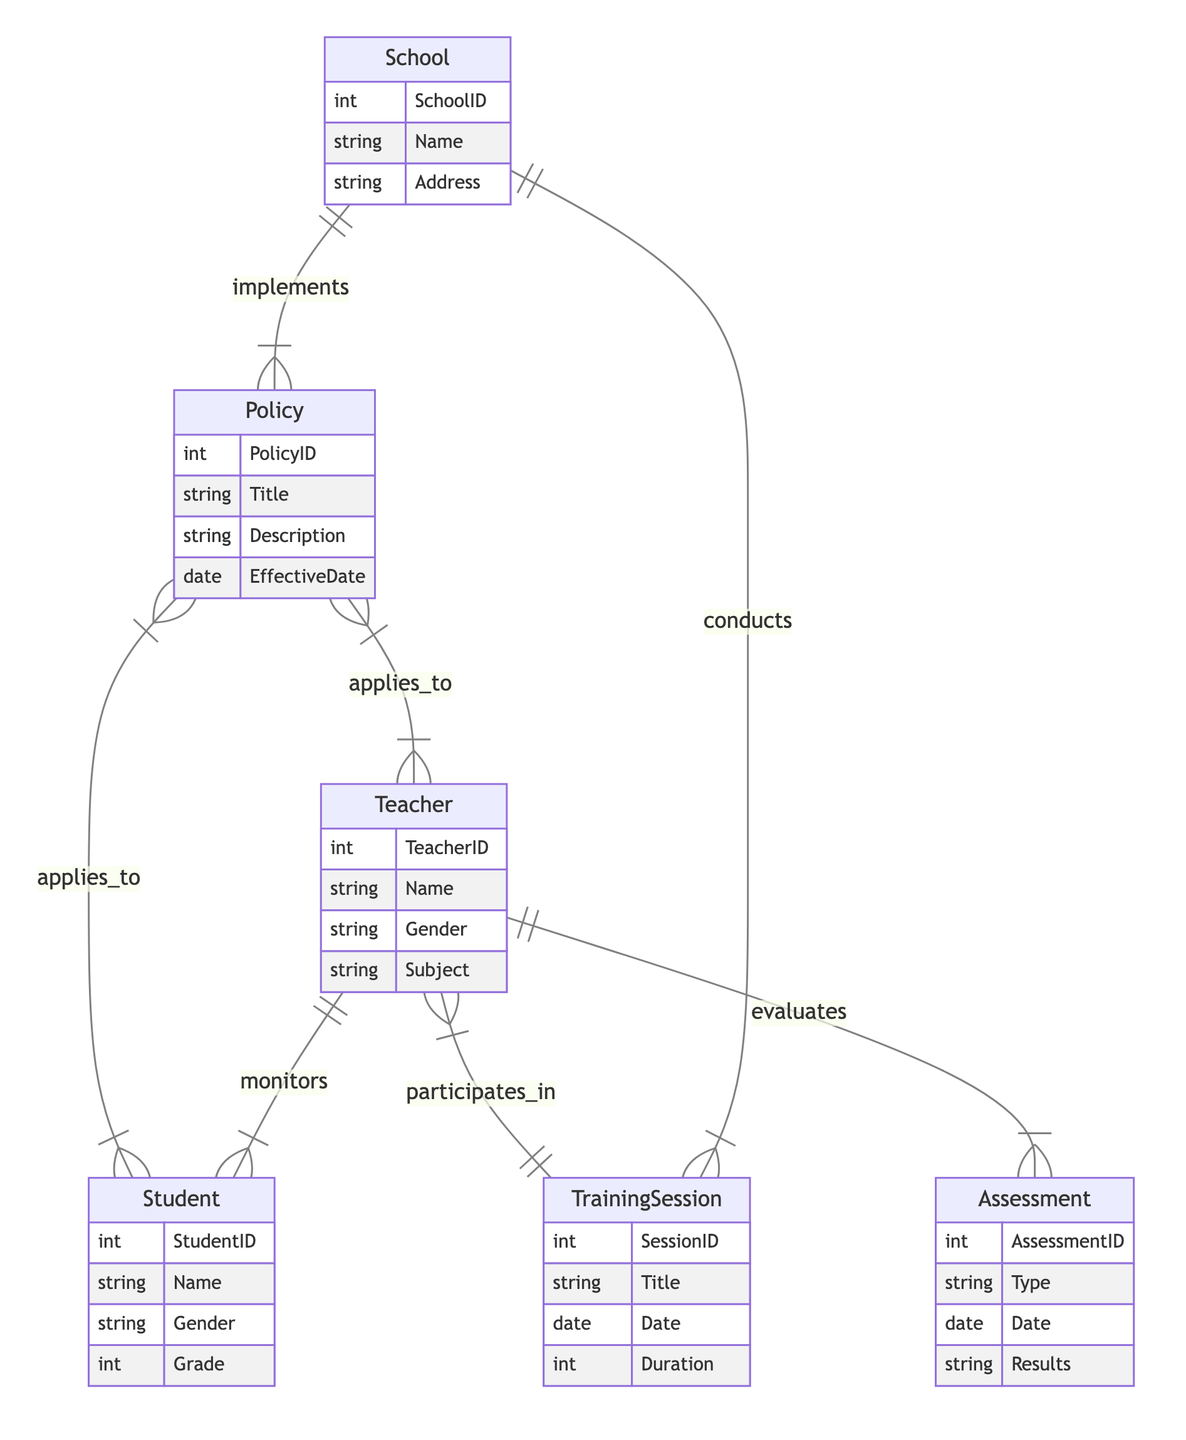What is the primary entity that implements policies? The diagram shows a direct relationship where the "School" entity implements the "Policy" entity. Since it's at the start of the relationship in the diagram, it indicates that schools are the primary entities carrying out the policies.
Answer: School How many entities are in this diagram? By counting the listed entities in the diagram, we see there are six distinct entities: School, Policy, Teacher, Student, TrainingSession, and Assessment. Therefore, the total is six entities.
Answer: Six Which entity monitors students? In the diagram, the relationship demonstrates that the "Teacher" entity is responsible for monitoring students, as indicated by the line connecting "Teacher" to "Student" with the "monitors" relationship.
Answer: Teacher How many relationships exist between teachers and training sessions? The diagram displays a single relationship line connecting "Teacher" and "TrainingSession," marked by the "participates_in" relationship, indicating there is only one relationship between them in this context.
Answer: One Which entity applies to both students and teachers? The "Policy" entity is shown with two lines indicating it applies to both "Student" and "Teacher" entities, demonstrating that policies are relevant to both groups.
Answer: Policy What is the type of relationship between schools and training sessions? The diagram clearly shows that the relationship between "School" and "TrainingSession" is a "conducts" relationship, indicating that schools conduct training sessions.
Answer: conducts How many assessments are evaluated by teachers? There is one direct relationship depicted between "Teacher" and "Assessment," which indicates that teachers evaluate assessments, and thus, there is one relationship in this context.
Answer: One What attributes does the Student entity contain? The attributes for the "Student" entity are: StudentID, Name, Gender, and Grade, as clearly specified in the entity list.
Answer: StudentID, Name, Gender, Grade Which entity is connected to policies with an "applies_to" relationship? The diagram shows that both "Student" and "Teacher" entities are connected to the "Policy" entity through the "applies_to" relationship, indicating that these entities are subject to school policies.
Answer: Student, Teacher 